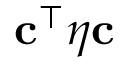<formula> <loc_0><loc_0><loc_500><loc_500>c ^ { \top } \boldsymbol \eta c</formula> 